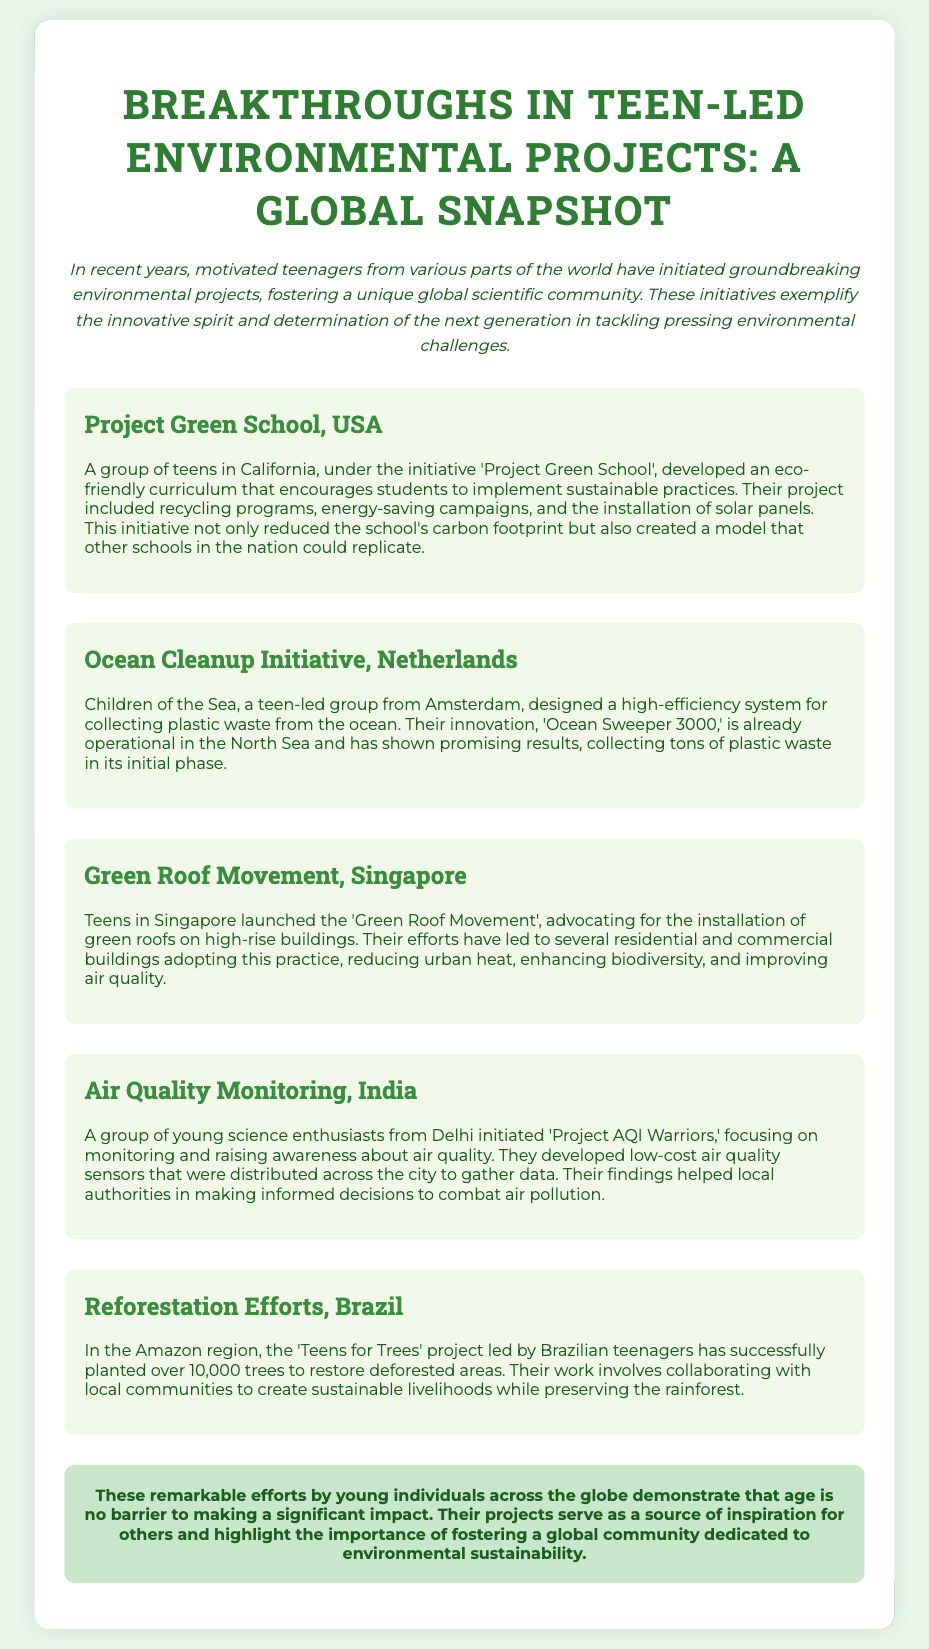What is the title of the document? The title of the document is stated at the top as "Breakthroughs in Teen-led Environmental Projects: A Global Snapshot."
Answer: Breakthroughs in Teen-led Environmental Projects: A Global Snapshot How many trees have been planted by the 'Teens for Trees' project? The document states that the 'Teens for Trees' project has successfully planted over 10,000 trees.
Answer: 10,000 What innovation did the teen-led group from Amsterdam create? The document mentions that the group designed a high-efficiency system for collecting plastic waste called 'Ocean Sweeper 3000.'
Answer: Ocean Sweeper 3000 Which initiative focuses on air quality in Delhi? The initiative mentioned for Delhi in the document is called 'Project AQI Warriors.'
Answer: Project AQI Warriors What is one benefit of the 'Green Roof Movement' mentioned in Singapore? The document states that the 'Green Roof Movement' reduces urban heat.
Answer: Reduces urban heat What type of project is 'Project Green School'? According to the document, 'Project Green School' developed an eco-friendly curriculum.
Answer: Eco-friendly curriculum Which country is associated with the Ocean Cleanup Initiative? The document identifies the Netherlands as the country associated with the Ocean Cleanup Initiative.
Answer: Netherlands What is a goal of the "Teens for Trees" project? The document states that the goal of the project is to restore deforested areas.
Answer: Restore deforested areas 